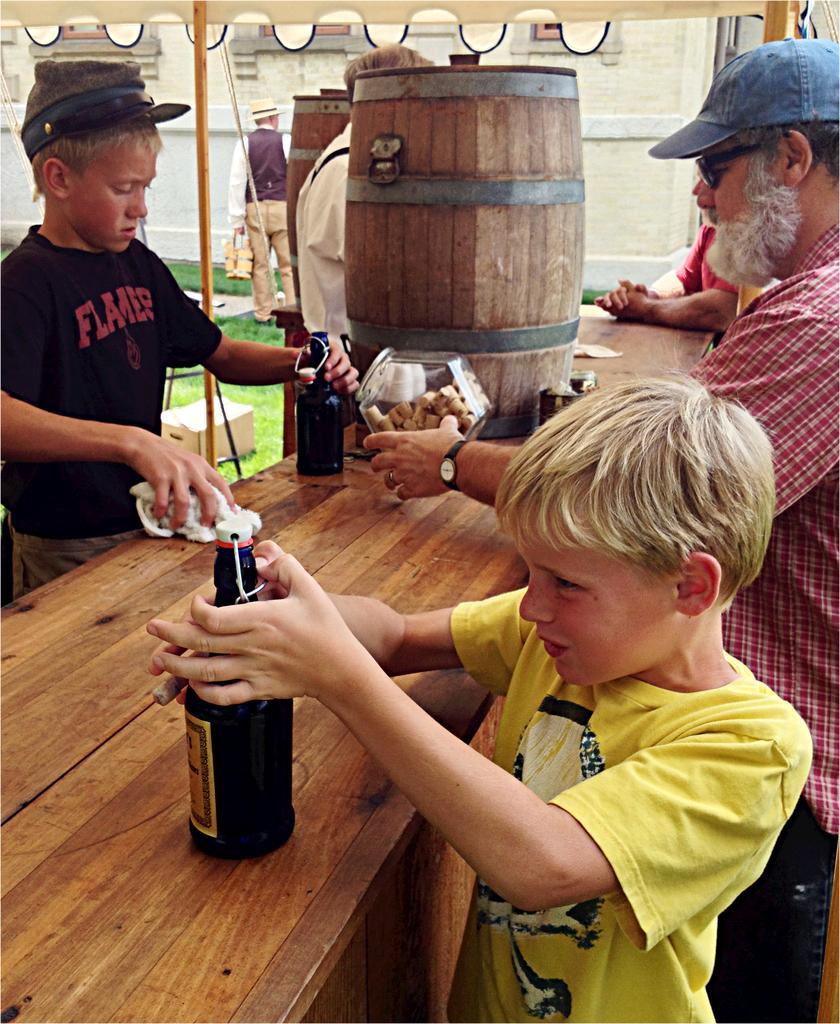Can you describe this image briefly? In this image we can see a child holding a bottle which is placed on the table. In the background we can see people standing near the table and a wooden can. 